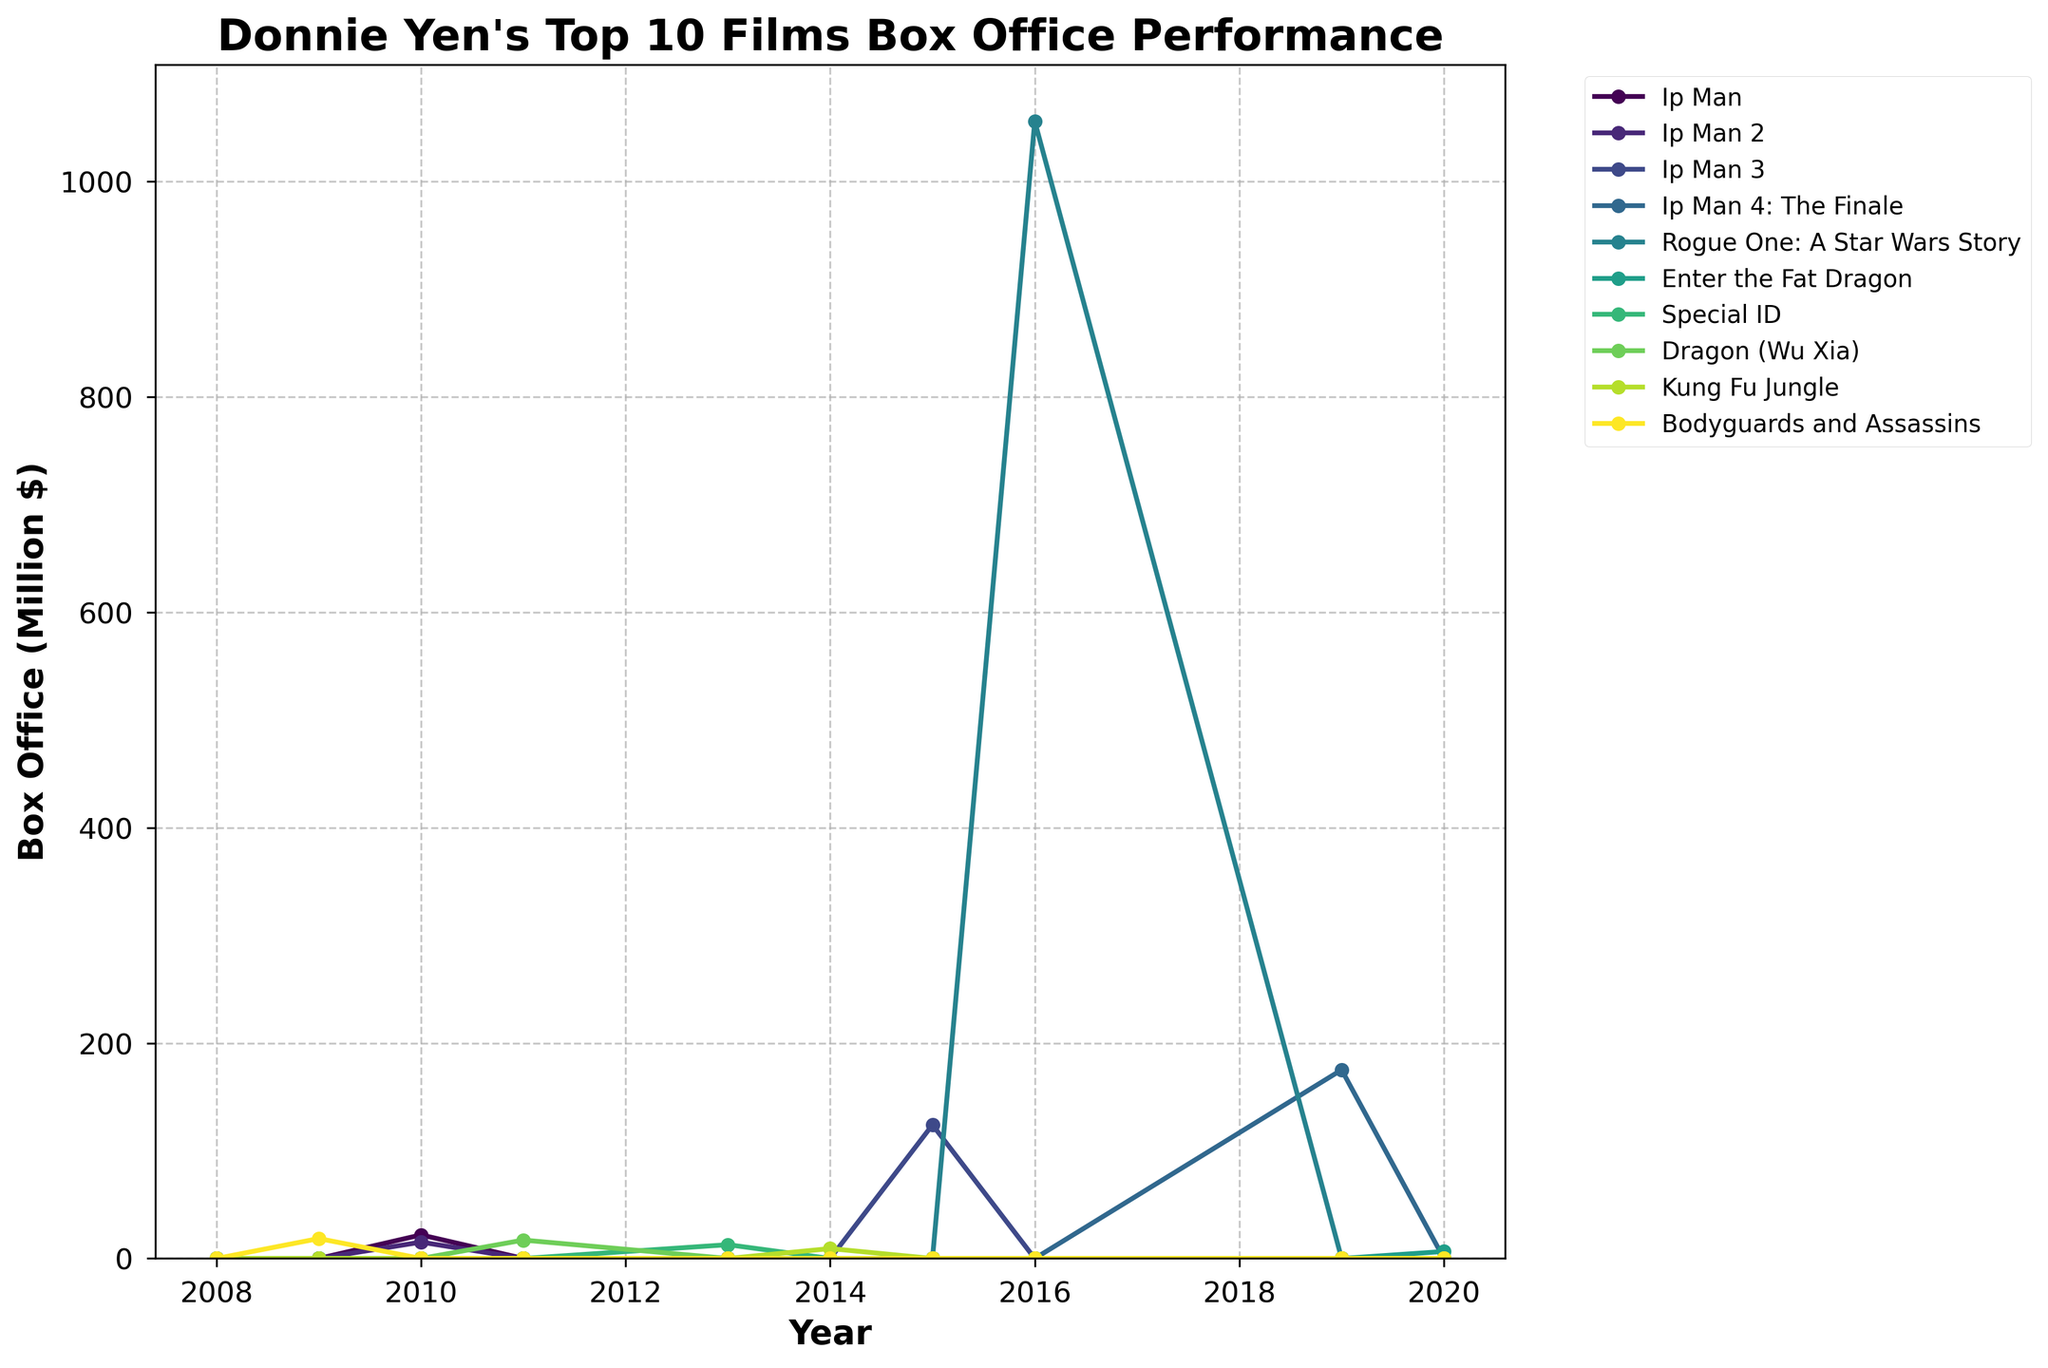Which Donnie Yen film had the highest box office performance, and in what year? The highest peak on the chart corresponds to "Rogue One: A Star Wars Story" in the year 2016.
Answer: Rogue One: A Star Wars Story, 2016 In which year did "Ip Man 3" achieve its box office peak, and what was the value? Look at the data points for "Ip Man 3." The peak occurred in 2015 with a value of 124.1 million dollars.
Answer: 2015, 124.1 million dollars Which film had a box office performance in 2020 and what was its value? By looking at the chart, "Enter the Fat Dragon" had a box office performance in 2020 with a value of 6.5 million dollars.
Answer: Enter the Fat Dragon, 6.5 million dollars Between "Ip Man" and "Ip Man 2," which one had a higher box office performance in 2010? Compare the values for 2010 for both films. "Ip Man" had 21.9 million dollars, while "Ip Man 2" had 15.2 million dollars.
Answer: Ip Man Which film showed a box office performance jump from 2009 to 2010? From 2009 to 2010, only "Ip Man" and "Ip Man 2" have values and show the increase. "Ip Man" and "Ip Man 2" jumped from 0 to 21.9 million dollars and 15.2 million dollars, respectively.
Answer: Ip Man and Ip Man 2 What was the box office performance of "Dragon (Wu Xia)" in 2011? Refer to the line for "Dragon (Wu Xia)" in 2011. The value is 17.1 million dollars.
Answer: 17.1 million dollars Which years had more than one film with a box office performance, and which films were they? Look for years with multiple data points above zero. In 2010, "Ip Man" and "Ip Man 2" had 21.9 million dollars and 15.2 million dollars, respectively.
Answer: 2010: Ip Man, Ip Man 2 Calculate the average box office performance of "Bodyguards and Assassins" across all the years it had values. "Bodyguards and Assassins" had a value of 18.5 million dollars in 2009. Sum these values and divide by the number of years with values. (18.5) / 1 = 18.5
Answer: 18.5 million dollars How did the box office performance of "Kung Fu Jungle" in 2014 compare to "Enter the Fat Dragon" in 2020? Compare the values for the two films in their respective years. "Kung Fu Jungle" had 9.2 million dollars, while "Enter the Fat Dragon" had 6.5 million dollars.
Answer: Kung Fu Jungle was higher What is the total box office performance of all films in 2016? Sum the box office values for all films in 2016. Only "Rogue One: A Star Wars Story" had a value of 1056.1 million dollars.
Answer: 1056.1 million dollars 